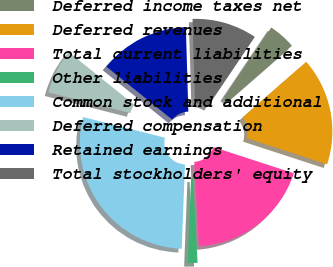<chart> <loc_0><loc_0><loc_500><loc_500><pie_chart><fcel>Deferred income taxes net<fcel>Deferred revenues<fcel>Total current liabilities<fcel>Other liabilities<fcel>Common stock and additional<fcel>Deferred compensation<fcel>Retained earnings<fcel>Total stockholders' equity<nl><fcel>4.15%<fcel>16.44%<fcel>19.12%<fcel>1.47%<fcel>28.33%<fcel>6.84%<fcel>13.75%<fcel>9.9%<nl></chart> 